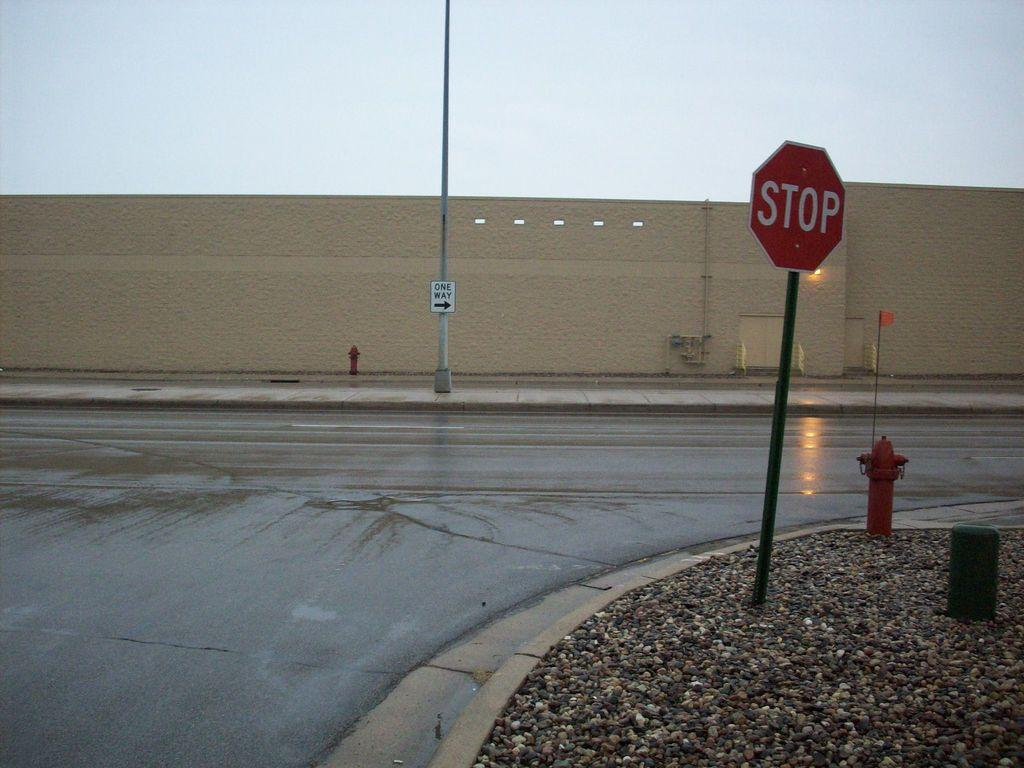<image>
Create a compact narrative representing the image presented. A stop sign and a one way sign are shown on the same street. 